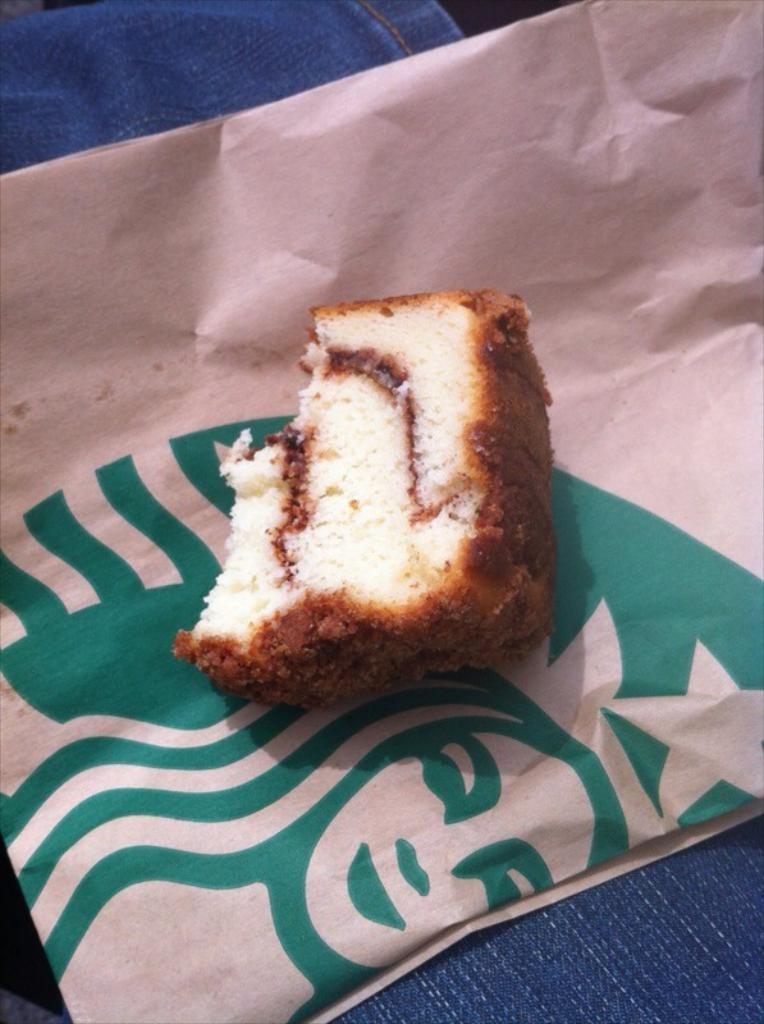Can you describe this image briefly? In the image there is a bread piece on a cover, below it seems to be a cloth. 